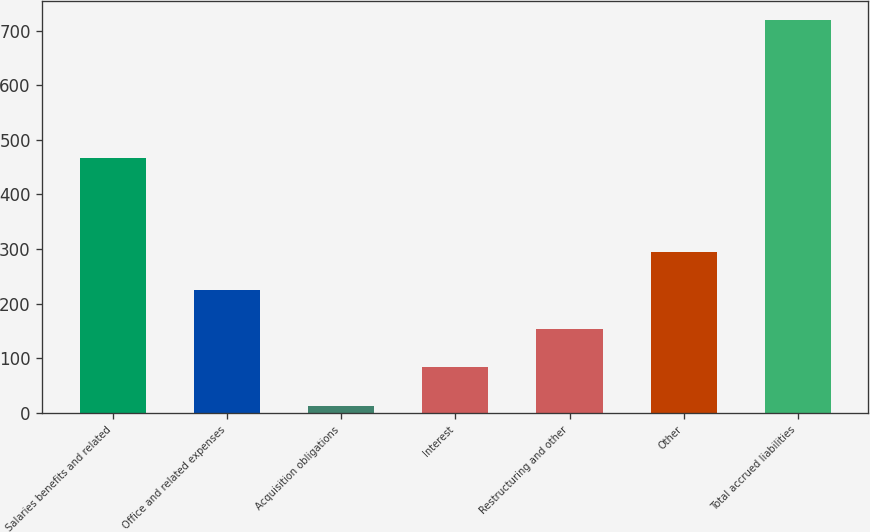Convert chart. <chart><loc_0><loc_0><loc_500><loc_500><bar_chart><fcel>Salaries benefits and related<fcel>Office and related expenses<fcel>Acquisition obligations<fcel>Interest<fcel>Restructuring and other<fcel>Other<fcel>Total accrued liabilities<nl><fcel>467.2<fcel>224.48<fcel>12.8<fcel>83.36<fcel>153.92<fcel>295.04<fcel>718.4<nl></chart> 